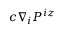Convert formula to latex. <formula><loc_0><loc_0><loc_500><loc_500>c \nabla _ { i } P ^ { i z }</formula> 